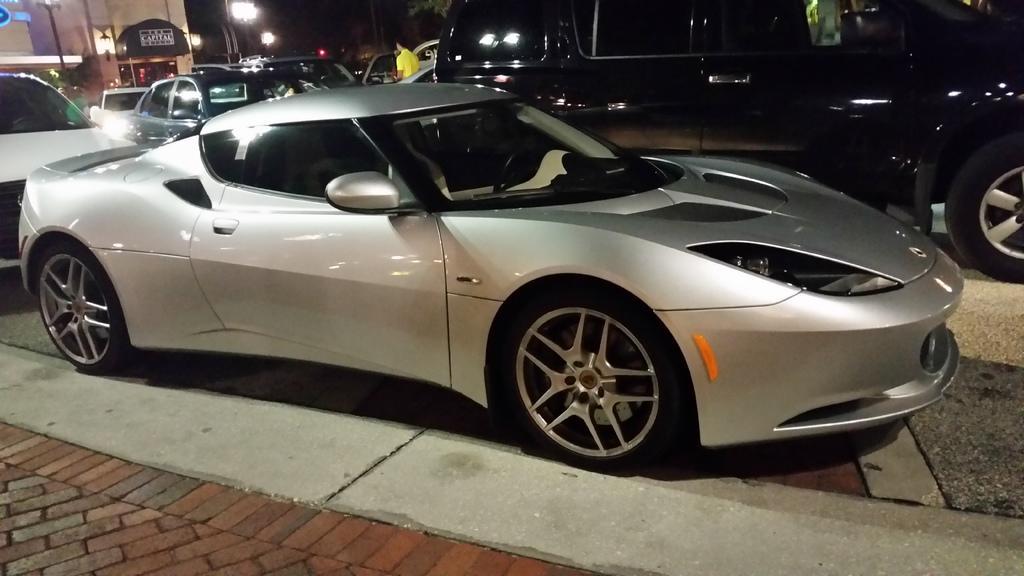Could you give a brief overview of what you see in this image? In this image there is the sky, there are lights, there is a building truncated towards the left of the image, there are vehicles on the road, there is a person standing, there is a vehicle truncated towards the right of the image, there is a vehicle truncated towards the left of the image. 